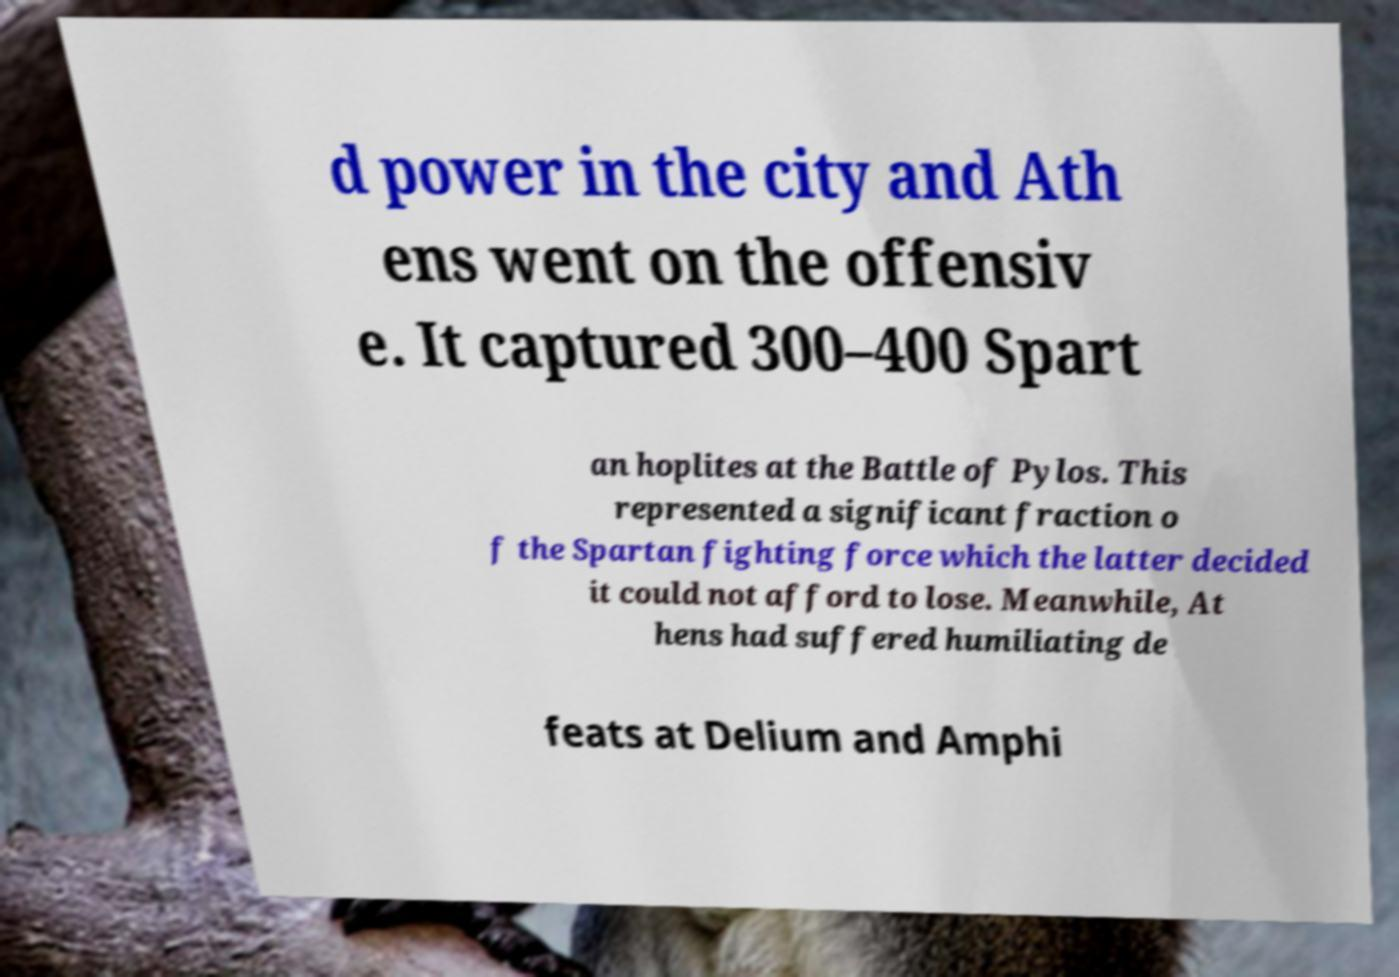I need the written content from this picture converted into text. Can you do that? d power in the city and Ath ens went on the offensiv e. It captured 300–400 Spart an hoplites at the Battle of Pylos. This represented a significant fraction o f the Spartan fighting force which the latter decided it could not afford to lose. Meanwhile, At hens had suffered humiliating de feats at Delium and Amphi 